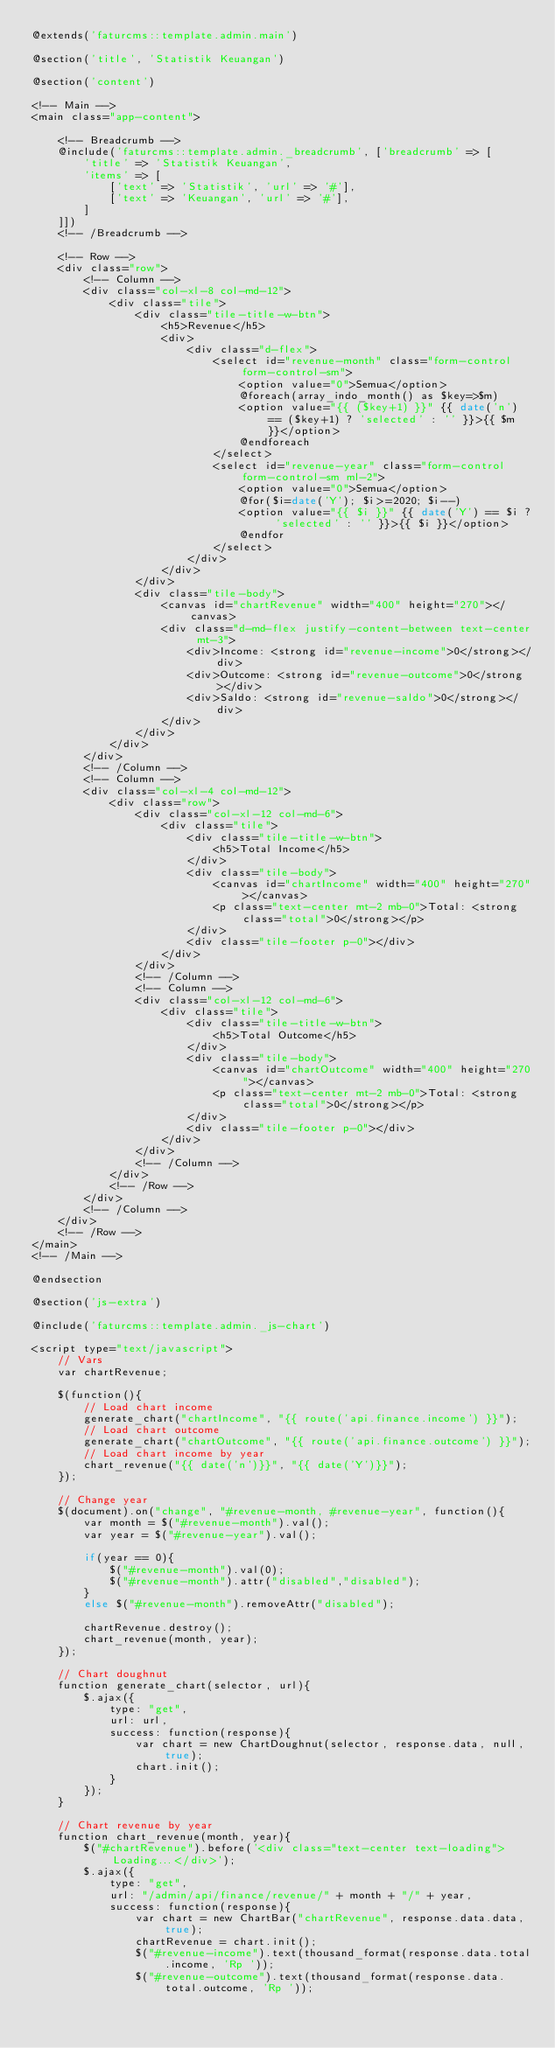<code> <loc_0><loc_0><loc_500><loc_500><_PHP_>@extends('faturcms::template.admin.main')

@section('title', 'Statistik Keuangan')

@section('content')

<!-- Main -->
<main class="app-content">

    <!-- Breadcrumb -->
    @include('faturcms::template.admin._breadcrumb', ['breadcrumb' => [
        'title' => 'Statistik Keuangan',
        'items' => [
            ['text' => 'Statistik', 'url' => '#'],
            ['text' => 'Keuangan', 'url' => '#'],
        ]
    ]])
    <!-- /Breadcrumb -->

    <!-- Row -->
    <div class="row">
        <!-- Column -->
        <div class="col-xl-8 col-md-12">
            <div class="tile">
                <div class="tile-title-w-btn">
                    <h5>Revenue</h5>
                    <div>
                        <div class="d-flex">
                            <select id="revenue-month" class="form-control form-control-sm">
                                <option value="0">Semua</option>
                                @foreach(array_indo_month() as $key=>$m)
                                <option value="{{ ($key+1) }}" {{ date('n') == ($key+1) ? 'selected' : '' }}>{{ $m }}</option>
                                @endforeach
                            </select>
                            <select id="revenue-year" class="form-control form-control-sm ml-2">
                                <option value="0">Semua</option>
                                @for($i=date('Y'); $i>=2020; $i--)
                                <option value="{{ $i }}" {{ date('Y') == $i ? 'selected' : '' }}>{{ $i }}</option>
                                @endfor
                            </select>
                        </div>
                    </div>
                </div>
                <div class="tile-body">
                    <canvas id="chartRevenue" width="400" height="270"></canvas>
                    <div class="d-md-flex justify-content-between text-center mt-3">
                        <div>Income: <strong id="revenue-income">0</strong></div>
                        <div>Outcome: <strong id="revenue-outcome">0</strong></div>
                        <div>Saldo: <strong id="revenue-saldo">0</strong></div>
                    </div>
                </div>
            </div>
        </div>
        <!-- /Column -->
        <!-- Column -->
        <div class="col-xl-4 col-md-12">
            <div class="row">
                <div class="col-xl-12 col-md-6">
                    <div class="tile">
                        <div class="tile-title-w-btn">
                            <h5>Total Income</h5>
                        </div>
                        <div class="tile-body">
                            <canvas id="chartIncome" width="400" height="270"></canvas>
                            <p class="text-center mt-2 mb-0">Total: <strong class="total">0</strong></p>
                        </div>
                        <div class="tile-footer p-0"></div>
                    </div>
                </div>
                <!-- /Column -->
                <!-- Column -->
                <div class="col-xl-12 col-md-6">
                    <div class="tile">
                        <div class="tile-title-w-btn">
                            <h5>Total Outcome</h5>
                        </div>
                        <div class="tile-body">
                            <canvas id="chartOutcome" width="400" height="270"></canvas>
                            <p class="text-center mt-2 mb-0">Total: <strong class="total">0</strong></p>
                        </div>
                        <div class="tile-footer p-0"></div>
                    </div>
                </div>
                <!-- /Column -->
            </div>
            <!-- /Row -->
        </div>
        <!-- /Column -->
    </div>
    <!-- /Row -->
</main>
<!-- /Main -->

@endsection

@section('js-extra')

@include('faturcms::template.admin._js-chart')

<script type="text/javascript">
    // Vars
    var chartRevenue;

    $(function(){
        // Load chart income
        generate_chart("chartIncome", "{{ route('api.finance.income') }}");
        // Load chart outcome
        generate_chart("chartOutcome", "{{ route('api.finance.outcome') }}");
        // Load chart income by year
        chart_revenue("{{ date('n')}}", "{{ date('Y')}}");
    });

    // Change year
    $(document).on("change", "#revenue-month, #revenue-year", function(){
        var month = $("#revenue-month").val();
        var year = $("#revenue-year").val();

        if(year == 0){
            $("#revenue-month").val(0);
            $("#revenue-month").attr("disabled","disabled");
        }
        else $("#revenue-month").removeAttr("disabled");

        chartRevenue.destroy();
        chart_revenue(month, year);
    });

    // Chart doughnut
    function generate_chart(selector, url){
        $.ajax({
            type: "get",
            url: url,
            success: function(response){
                var chart = new ChartDoughnut(selector, response.data, null, true);
                chart.init();
            }
        });
    }

    // Chart revenue by year
    function chart_revenue(month, year){
        $("#chartRevenue").before('<div class="text-center text-loading">Loading...</div>');
        $.ajax({
            type: "get",
            url: "/admin/api/finance/revenue/" + month + "/" + year,
            success: function(response){
                var chart = new ChartBar("chartRevenue", response.data.data, true);
                chartRevenue = chart.init();
                $("#revenue-income").text(thousand_format(response.data.total.income, 'Rp '));
                $("#revenue-outcome").text(thousand_format(response.data.total.outcome, 'Rp '));</code> 